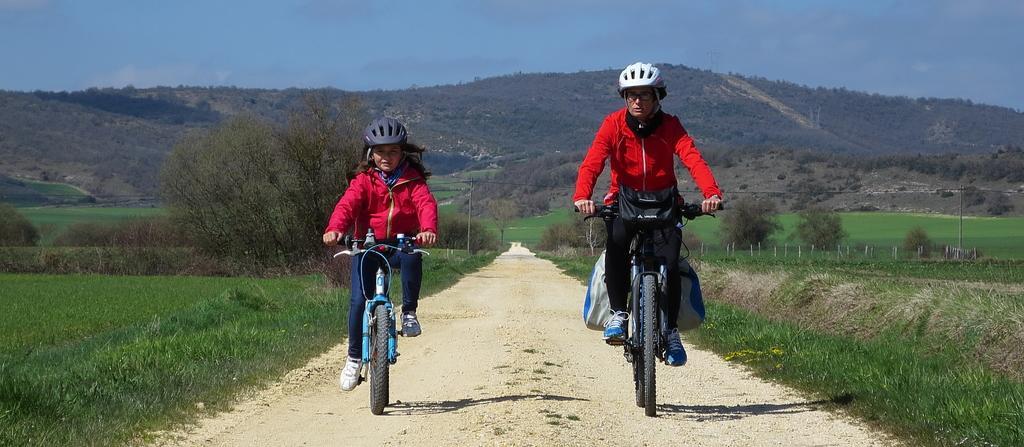Please provide a concise description of this image. In this image I can see a persons and a girl who are on the cycles and they are on the path and I see the grass and plants on both the sides. In the background I see the sky. 